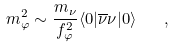<formula> <loc_0><loc_0><loc_500><loc_500>m _ { \varphi } ^ { 2 } \sim \frac { m _ { \nu } } { f _ { \varphi } ^ { 2 } } \langle 0 | \overline { \nu } \nu | 0 \rangle \quad ,</formula> 